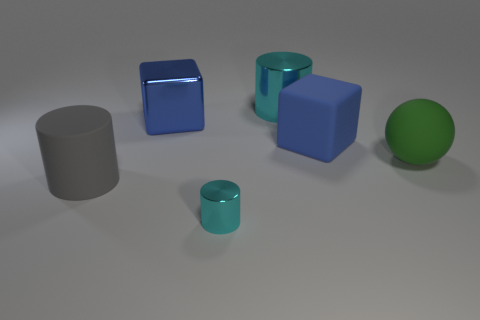Add 1 blue metallic objects. How many objects exist? 7 Subtract all cubes. How many objects are left? 4 Subtract all large green rubber balls. Subtract all large purple metallic objects. How many objects are left? 5 Add 1 metallic cylinders. How many metallic cylinders are left? 3 Add 4 big blue cylinders. How many big blue cylinders exist? 4 Subtract 0 red cylinders. How many objects are left? 6 